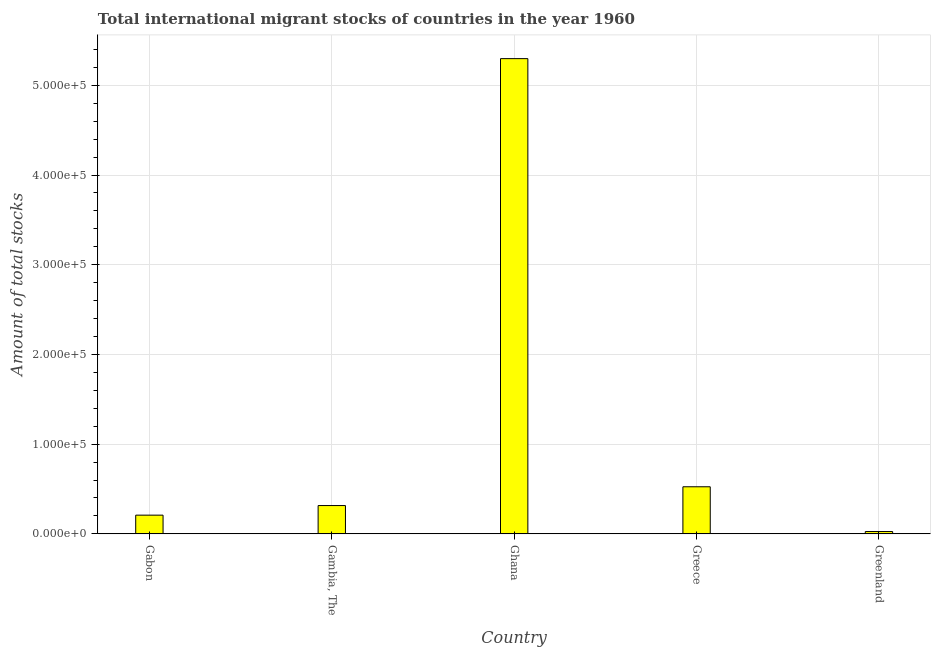What is the title of the graph?
Offer a very short reply. Total international migrant stocks of countries in the year 1960. What is the label or title of the X-axis?
Make the answer very short. Country. What is the label or title of the Y-axis?
Your response must be concise. Amount of total stocks. What is the total number of international migrant stock in Gambia, The?
Your response must be concise. 3.16e+04. Across all countries, what is the maximum total number of international migrant stock?
Offer a terse response. 5.30e+05. Across all countries, what is the minimum total number of international migrant stock?
Your answer should be compact. 2591. In which country was the total number of international migrant stock minimum?
Ensure brevity in your answer.  Greenland. What is the sum of the total number of international migrant stock?
Offer a terse response. 6.37e+05. What is the difference between the total number of international migrant stock in Ghana and Greece?
Provide a succinct answer. 4.77e+05. What is the average total number of international migrant stock per country?
Keep it short and to the point. 1.27e+05. What is the median total number of international migrant stock?
Provide a short and direct response. 3.16e+04. What is the ratio of the total number of international migrant stock in Gabon to that in Gambia, The?
Your answer should be compact. 0.66. What is the difference between the highest and the second highest total number of international migrant stock?
Your answer should be very brief. 4.77e+05. What is the difference between the highest and the lowest total number of international migrant stock?
Offer a terse response. 5.27e+05. In how many countries, is the total number of international migrant stock greater than the average total number of international migrant stock taken over all countries?
Make the answer very short. 1. How many bars are there?
Offer a terse response. 5. Are all the bars in the graph horizontal?
Ensure brevity in your answer.  No. How many countries are there in the graph?
Keep it short and to the point. 5. Are the values on the major ticks of Y-axis written in scientific E-notation?
Make the answer very short. Yes. What is the Amount of total stocks of Gabon?
Ensure brevity in your answer.  2.09e+04. What is the Amount of total stocks of Gambia, The?
Offer a very short reply. 3.16e+04. What is the Amount of total stocks in Ghana?
Provide a short and direct response. 5.30e+05. What is the Amount of total stocks of Greece?
Your response must be concise. 5.25e+04. What is the Amount of total stocks in Greenland?
Ensure brevity in your answer.  2591. What is the difference between the Amount of total stocks in Gabon and Gambia, The?
Keep it short and to the point. -1.07e+04. What is the difference between the Amount of total stocks in Gabon and Ghana?
Keep it short and to the point. -5.09e+05. What is the difference between the Amount of total stocks in Gabon and Greece?
Your response must be concise. -3.16e+04. What is the difference between the Amount of total stocks in Gabon and Greenland?
Offer a terse response. 1.83e+04. What is the difference between the Amount of total stocks in Gambia, The and Ghana?
Keep it short and to the point. -4.98e+05. What is the difference between the Amount of total stocks in Gambia, The and Greece?
Provide a succinct answer. -2.09e+04. What is the difference between the Amount of total stocks in Gambia, The and Greenland?
Provide a short and direct response. 2.90e+04. What is the difference between the Amount of total stocks in Ghana and Greece?
Your answer should be very brief. 4.77e+05. What is the difference between the Amount of total stocks in Ghana and Greenland?
Ensure brevity in your answer.  5.27e+05. What is the difference between the Amount of total stocks in Greece and Greenland?
Offer a terse response. 4.99e+04. What is the ratio of the Amount of total stocks in Gabon to that in Gambia, The?
Your response must be concise. 0.66. What is the ratio of the Amount of total stocks in Gabon to that in Ghana?
Give a very brief answer. 0.04. What is the ratio of the Amount of total stocks in Gabon to that in Greece?
Keep it short and to the point. 0.4. What is the ratio of the Amount of total stocks in Gabon to that in Greenland?
Your answer should be very brief. 8.05. What is the ratio of the Amount of total stocks in Gambia, The to that in Greece?
Provide a succinct answer. 0.6. What is the ratio of the Amount of total stocks in Gambia, The to that in Greenland?
Ensure brevity in your answer.  12.18. What is the ratio of the Amount of total stocks in Ghana to that in Greece?
Your answer should be compact. 10.09. What is the ratio of the Amount of total stocks in Ghana to that in Greenland?
Your response must be concise. 204.45. What is the ratio of the Amount of total stocks in Greece to that in Greenland?
Keep it short and to the point. 20.26. 